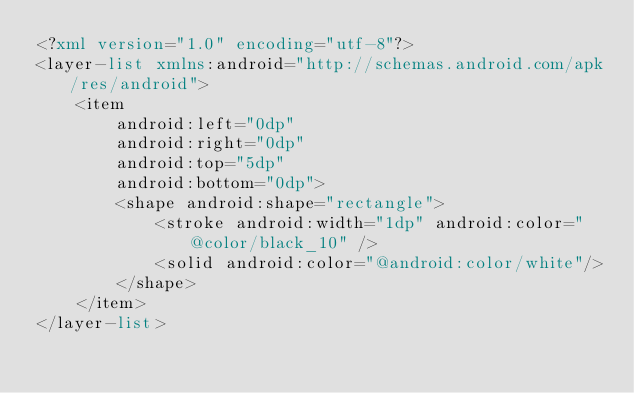<code> <loc_0><loc_0><loc_500><loc_500><_XML_><?xml version="1.0" encoding="utf-8"?>
<layer-list xmlns:android="http://schemas.android.com/apk/res/android">
    <item
        android:left="0dp"
        android:right="0dp"
        android:top="5dp"
        android:bottom="0dp">
        <shape android:shape="rectangle">
            <stroke android:width="1dp" android:color="@color/black_10" />
            <solid android:color="@android:color/white"/>
        </shape>
    </item>
</layer-list>

</code> 